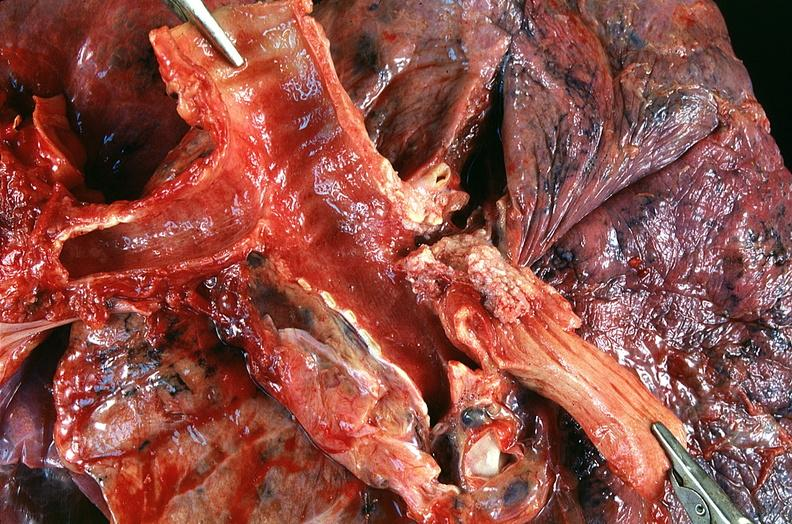what does this image show?
Answer the question using a single word or phrase. Lung 